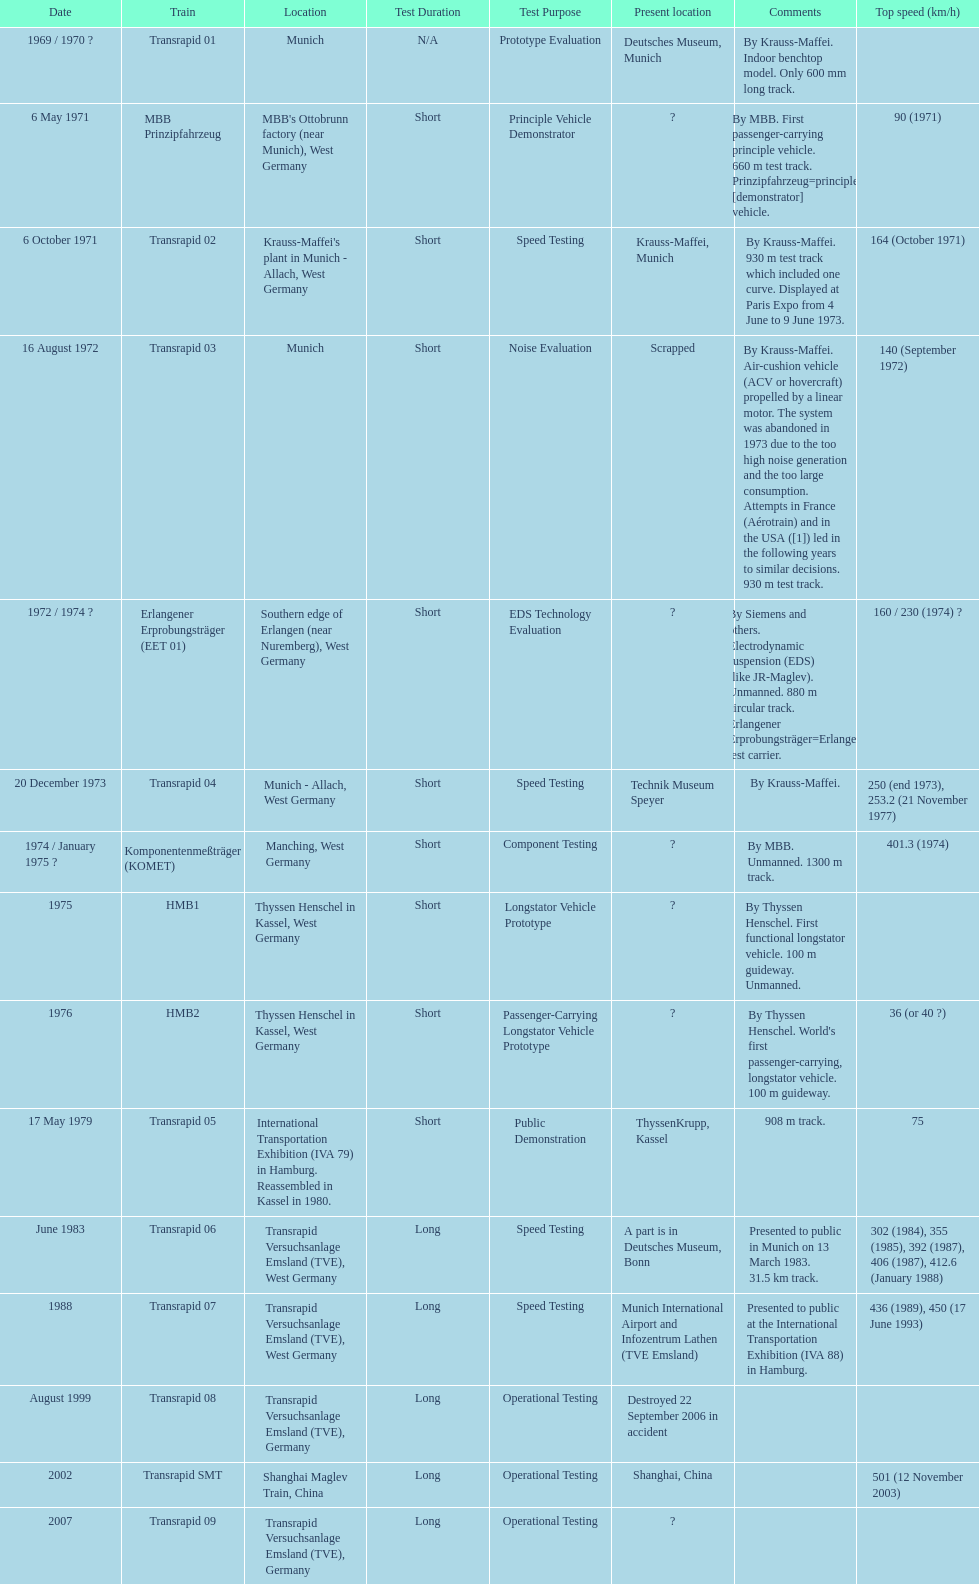High noise generation and too large consumption led to what train being scrapped? Transrapid 03. 